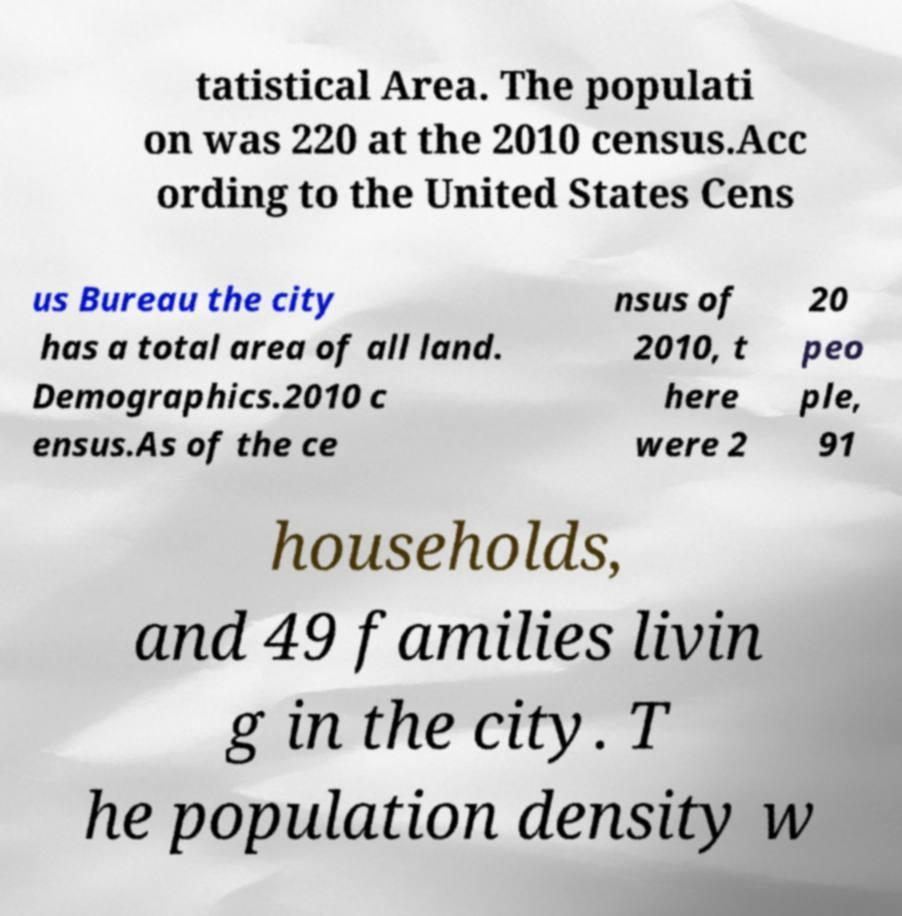Please read and relay the text visible in this image. What does it say? tatistical Area. The populati on was 220 at the 2010 census.Acc ording to the United States Cens us Bureau the city has a total area of all land. Demographics.2010 c ensus.As of the ce nsus of 2010, t here were 2 20 peo ple, 91 households, and 49 families livin g in the city. T he population density w 